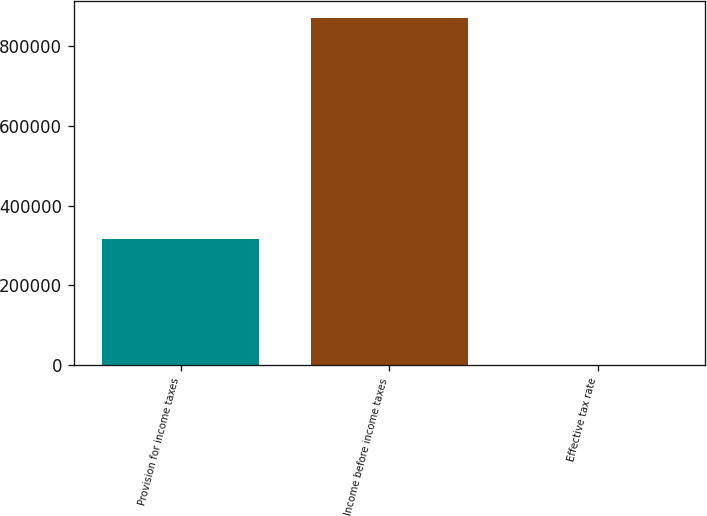<chart> <loc_0><loc_0><loc_500><loc_500><bar_chart><fcel>Provision for income taxes<fcel>Income before income taxes<fcel>Effective tax rate<nl><fcel>315309<fcel>869332<fcel>36.3<nl></chart> 